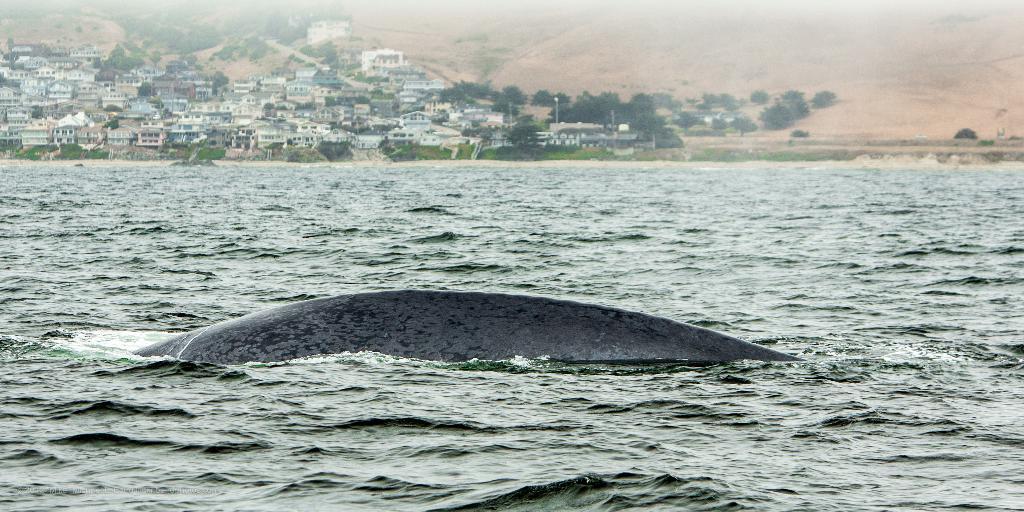Please provide a concise description of this image. In this picture I can see a fish in the water, and in the background there are buildings, trees and there is a hill. 